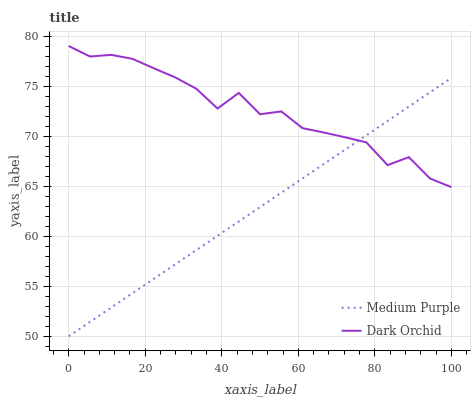Does Dark Orchid have the minimum area under the curve?
Answer yes or no. No. Is Dark Orchid the smoothest?
Answer yes or no. No. Does Dark Orchid have the lowest value?
Answer yes or no. No. 